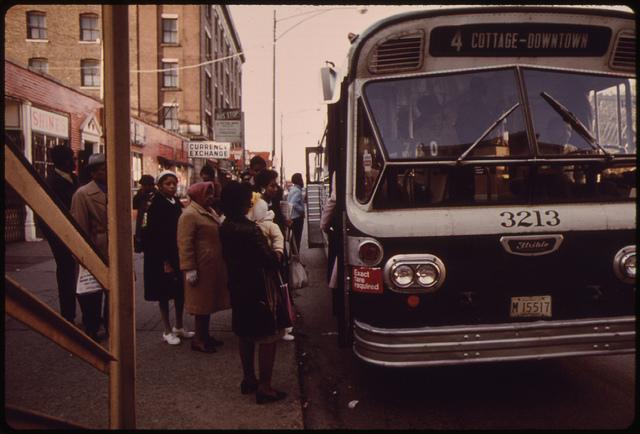What is the first letter on the license plate?
Be succinct. M. What number is on the bus front?
Concise answer only. 3213. Are people getting on or off the bus?
Write a very short answer. On. Is the lady getting on or off the bus?
Give a very brief answer. On. Are the people getting off the bus?
Short answer required. No. 